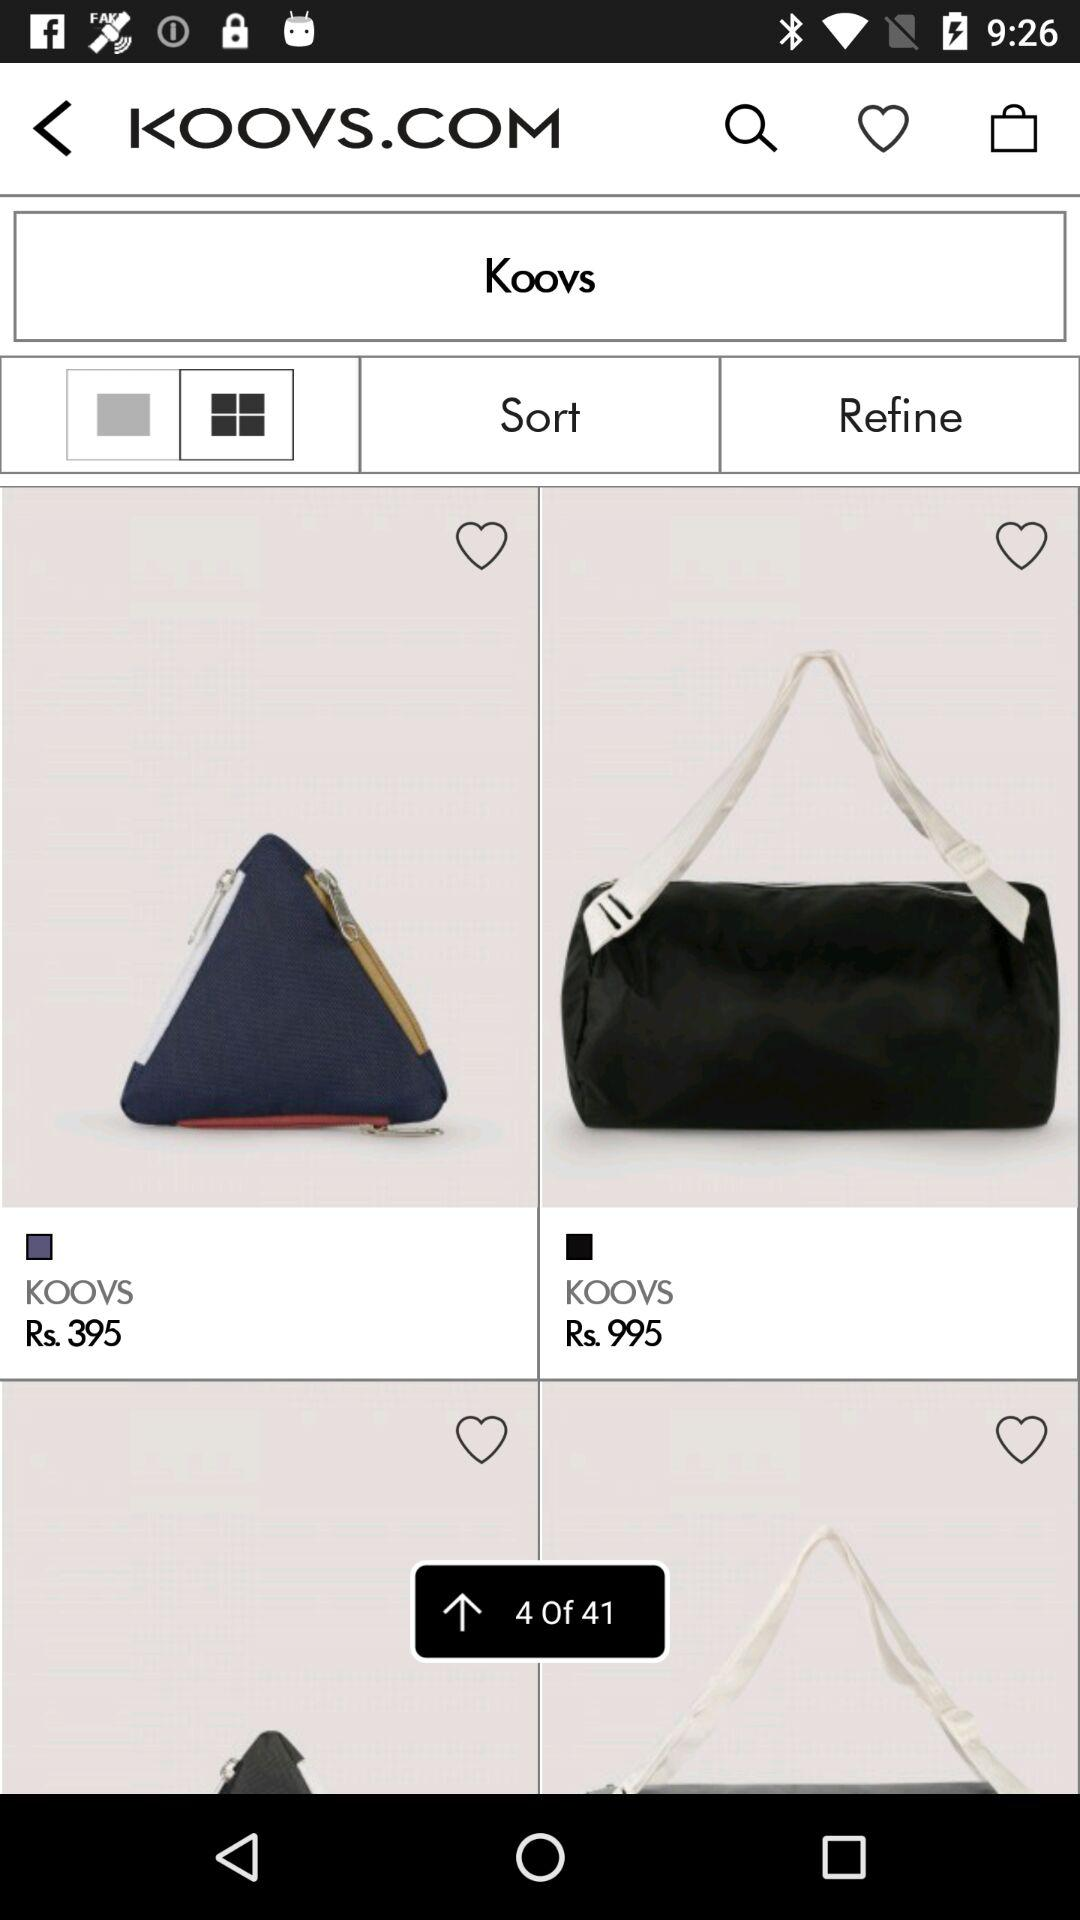What is the name of application?
When the provided information is insufficient, respond with <no answer>. <no answer> 